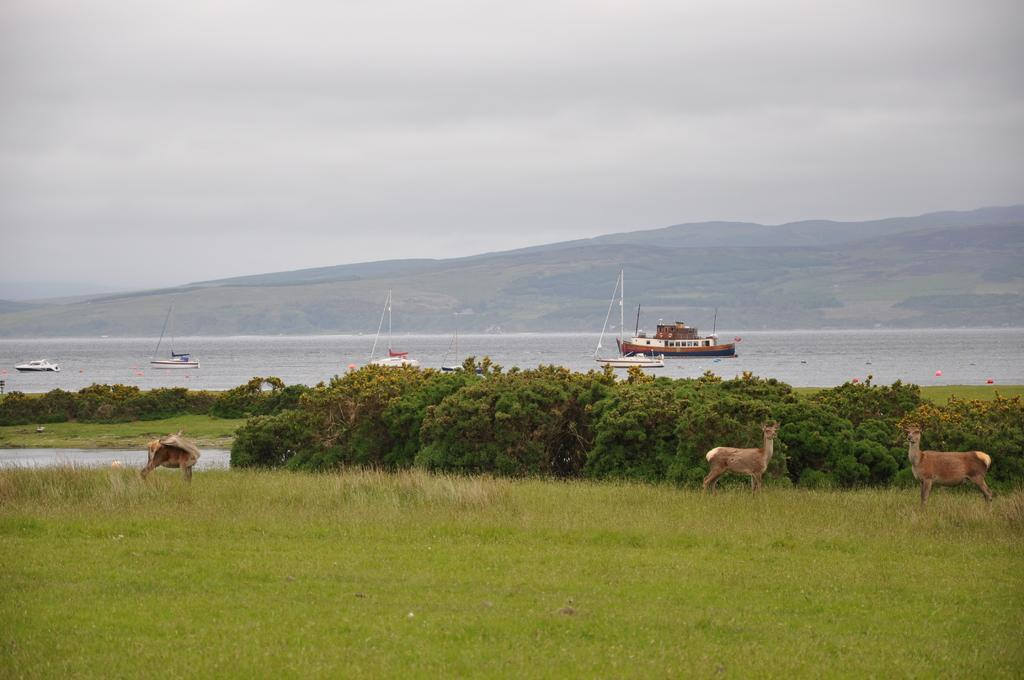Where was the image taken? The image was taken in a forest. What can be seen in the foreground of the image? In the foreground, there are plants, shrubs, grass, and a deer. What is visible in the center of the image? In the center of the image, there are boats, hills, and a water body. How would you describe the sky in the image? The sky in the image is cloudy. What type of fan is visible in the image? There is no fan present in the image. What is the income of the deer in the image? Deer do not have an income, and there is no information about the deer's financial status in the image. 